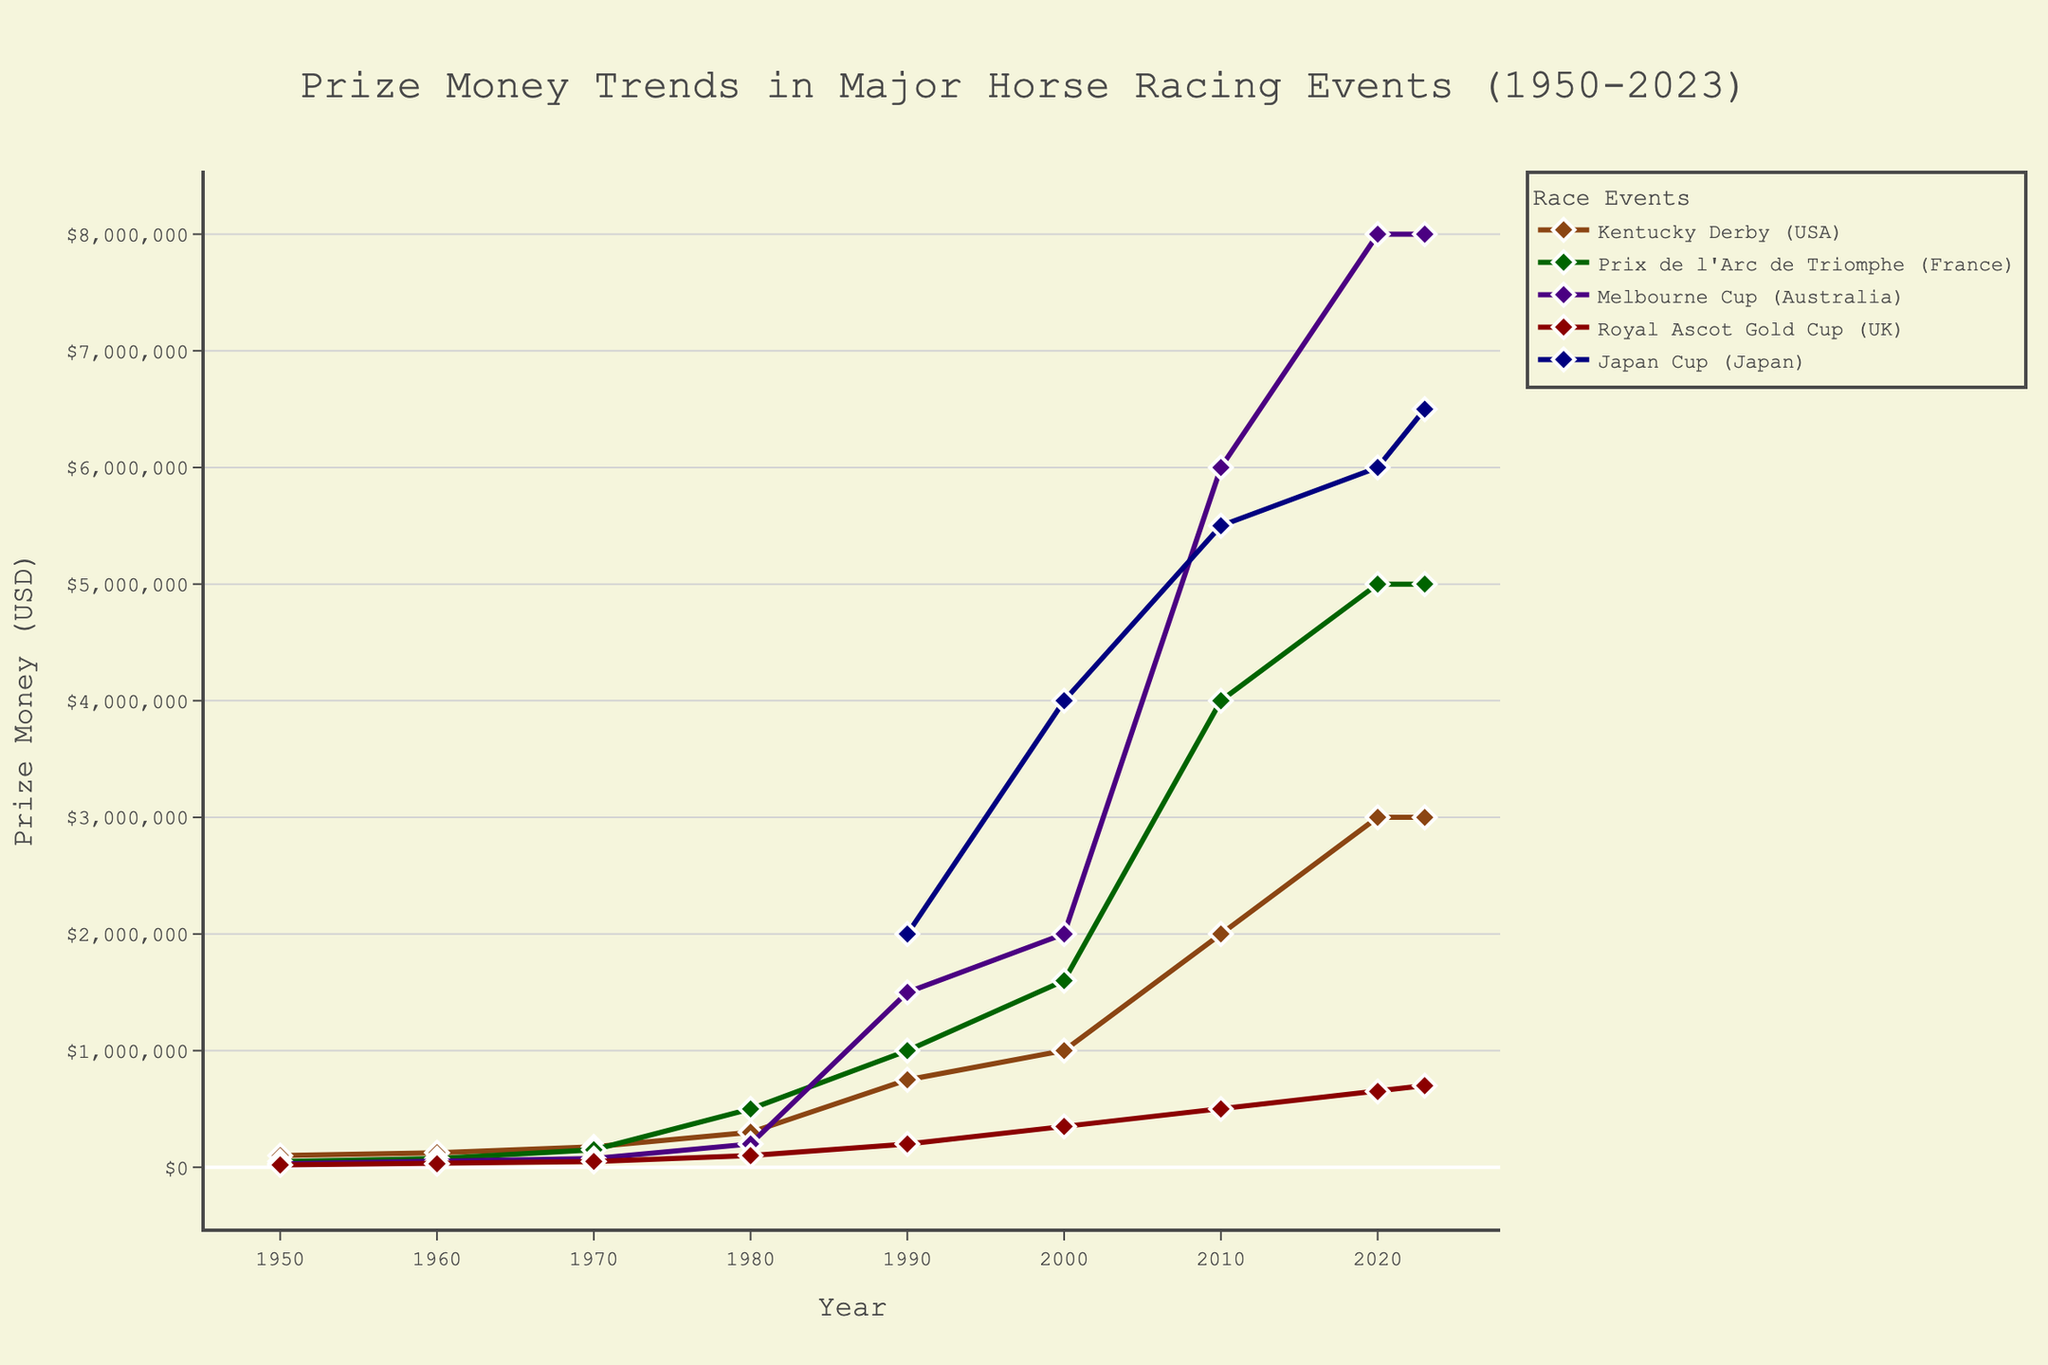Which horse racing event had the highest prize money in 1980? To find the answer, locate the year 1980 on the x-axis and check the y-values for each event. The event with the highest point on the y-axis represents the highest prize money. The Prix de l'Arc de Triomphe (France) surpasses other races with a prize of $500,000.
Answer: Prix de l'Arc de Triomphe (France) How much did the prize money for the Melbourne Cup increase from 1990 to 2020? Identify the points on the graph for the Melbourne Cup in 1990 and 2020. In 1990, it was $1,500,000 and in 2020, it was $8,000,000. Subtract the 1990 value from the 2020 value: $8,000,000 - $1,500,000 = $6,500,000.
Answer: $6,500,000 Which event showed the most significant increase in prize money between 2000 and 2010? Compare the slopes of the lines between 2000 and 2010 for all events. The Japan Cup shows an increase from $4,000,000 to $5,500,000. Calculate the changes for all events and determine the largest difference. The Japan Cup's increase is $1,500,000, which is the largest among the events in this period.
Answer: Japan Cup (Japan) What is the general trend in prize money for the Royal Ascot Gold Cup between 1950 and 2023? Track the line for the Royal Ascot Gold Cup from 1950 to 2023. The trend shows a steady increase over the years, starting from $20,000 in 1950 and reaching $700,000 in 2023.
Answer: Steady increase In what year did the Kentucky Derby cross the $1,000,000 prize money mark? Locate the line for the Kentucky Derby and identify when it surpasses the $1,000,000 mark on the y-axis. The prize money crosses the $1,000,000 threshold in 2000.
Answer: 2000 How does the prize money for the Prix de l'Arc de Triomphe in 2023 compare to that in 1980? Check the prize money values for the Prix de l'Arc de Triomphe in 1980 and 2023 from the graph. In 1980, it was $500,000, and in 2023, it is $5,000,000. To compare, the 2023 amount is significantly higher by $4,500,000.
Answer: $4,500,000 higher Which event had the least amount of prize money in the year 1960? Locate the year 1960 on the x-axis and find the y-values for all events. The Royal Ascot Gold Cup (UK) had a prize money of $30,000, which is the least among the events listed for that year.
Answer: Royal Ascot Gold Cup (UK) How did the prize money for the Japan Cup change from its introduction in 1990 to 2023? The Japan Cup starts in 1990 with a prize money of $2,000,000. Follow the line representing the Japan Cup to 2023, where it reaches $6,500,000. The increase is $6,500,000 - $2,000,000 = $4,500,000.
Answer: $4,500,000 increase What is the prize money difference between the Kentucky Derby and the Royal Ascot Gold Cup in 2023? Check the values for both events in 2023. The Kentucky Derby has $3,000,000, and the Royal Ascot Gold Cup has $700,000. The difference is $3,000,000 - $700,000 = $2,300,000.
Answer: $2,300,000 